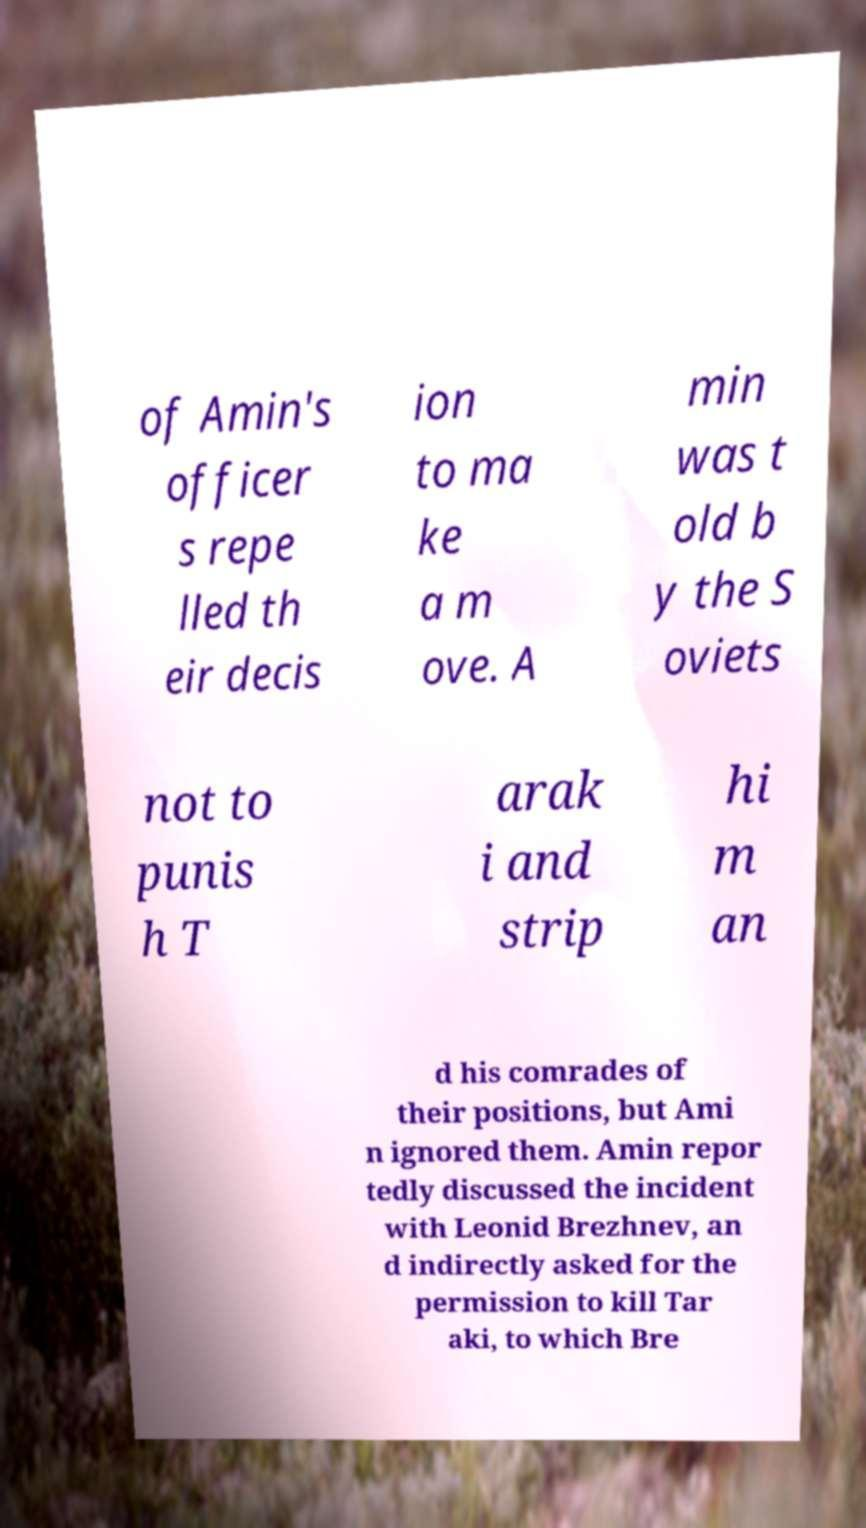Please read and relay the text visible in this image. What does it say? of Amin's officer s repe lled th eir decis ion to ma ke a m ove. A min was t old b y the S oviets not to punis h T arak i and strip hi m an d his comrades of their positions, but Ami n ignored them. Amin repor tedly discussed the incident with Leonid Brezhnev, an d indirectly asked for the permission to kill Tar aki, to which Bre 